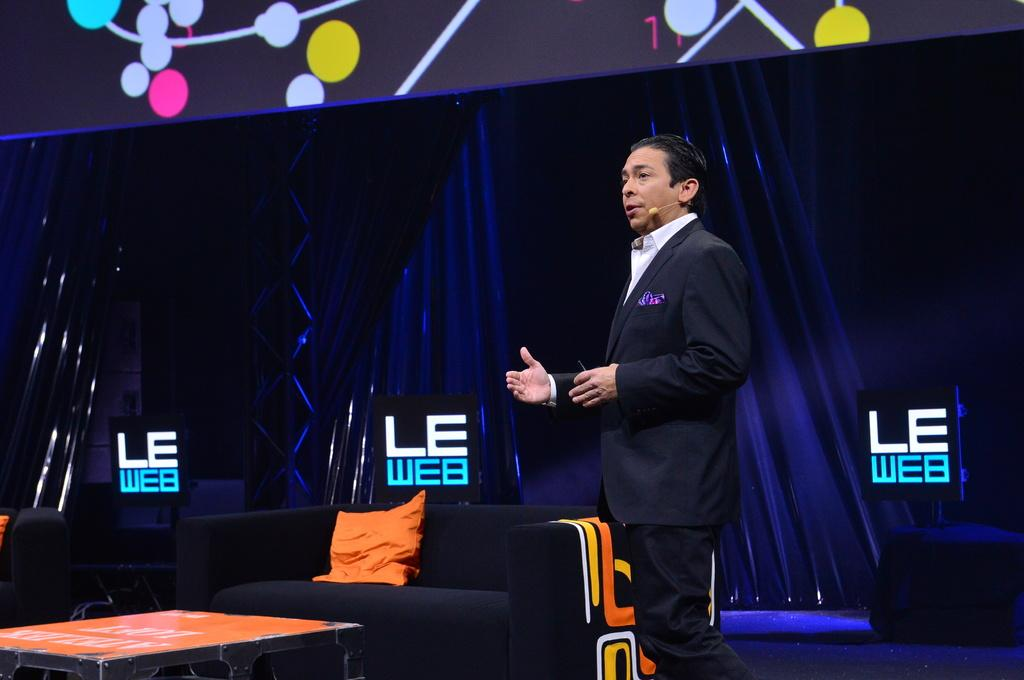<image>
Describe the image concisely. A man in a suit is in front of a sign that says LE WEB 